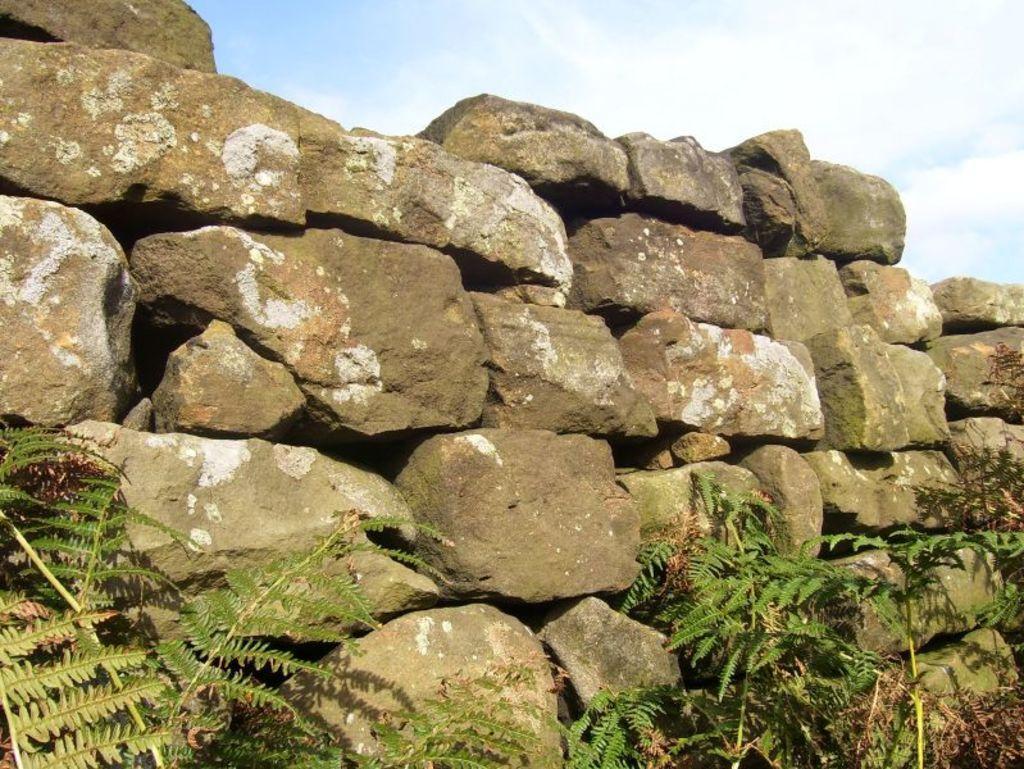Please provide a concise description of this image. In this image I can see at the bottom there are plants. In the middle there are stones. At the top it is the cloudy sky. 